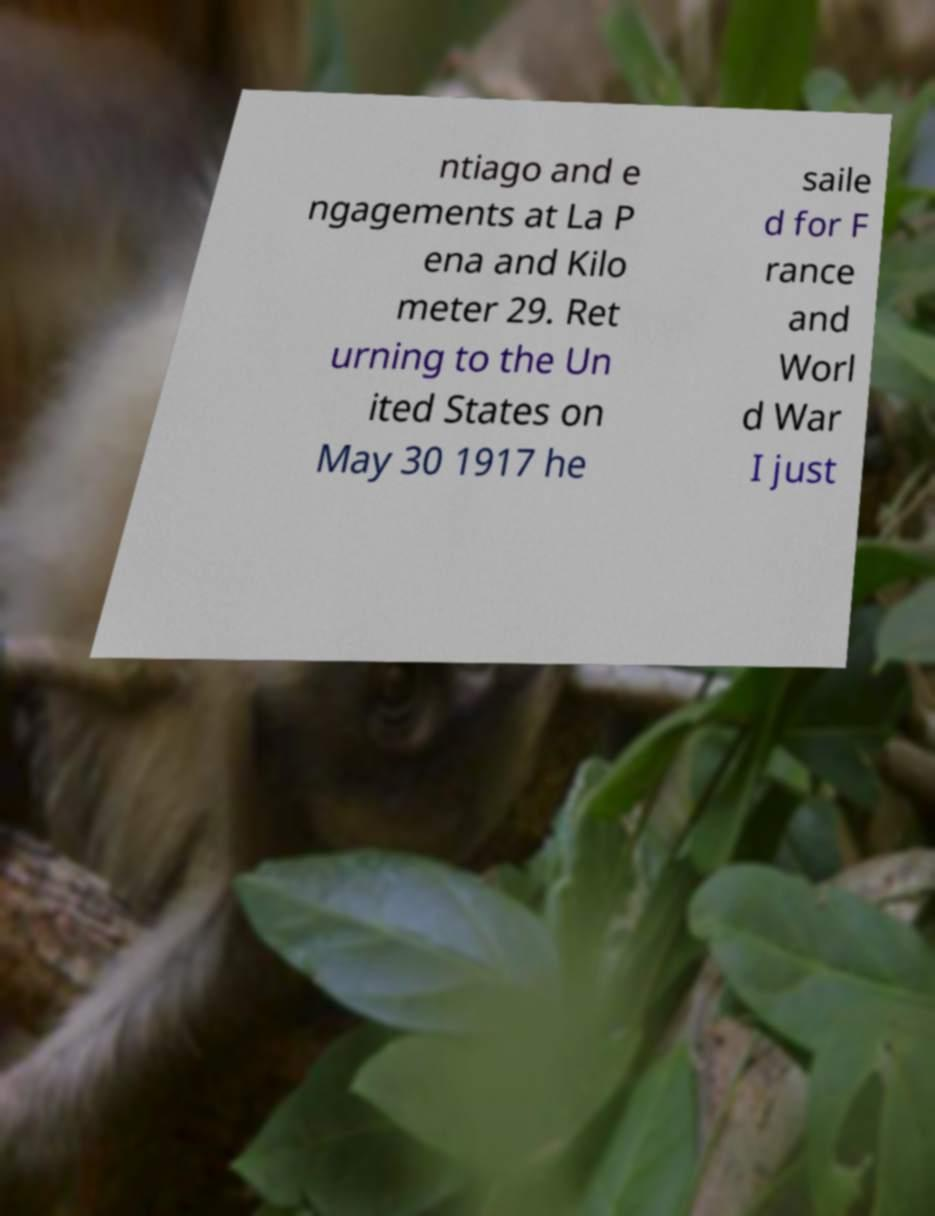Could you assist in decoding the text presented in this image and type it out clearly? ntiago and e ngagements at La P ena and Kilo meter 29. Ret urning to the Un ited States on May 30 1917 he saile d for F rance and Worl d War I just 